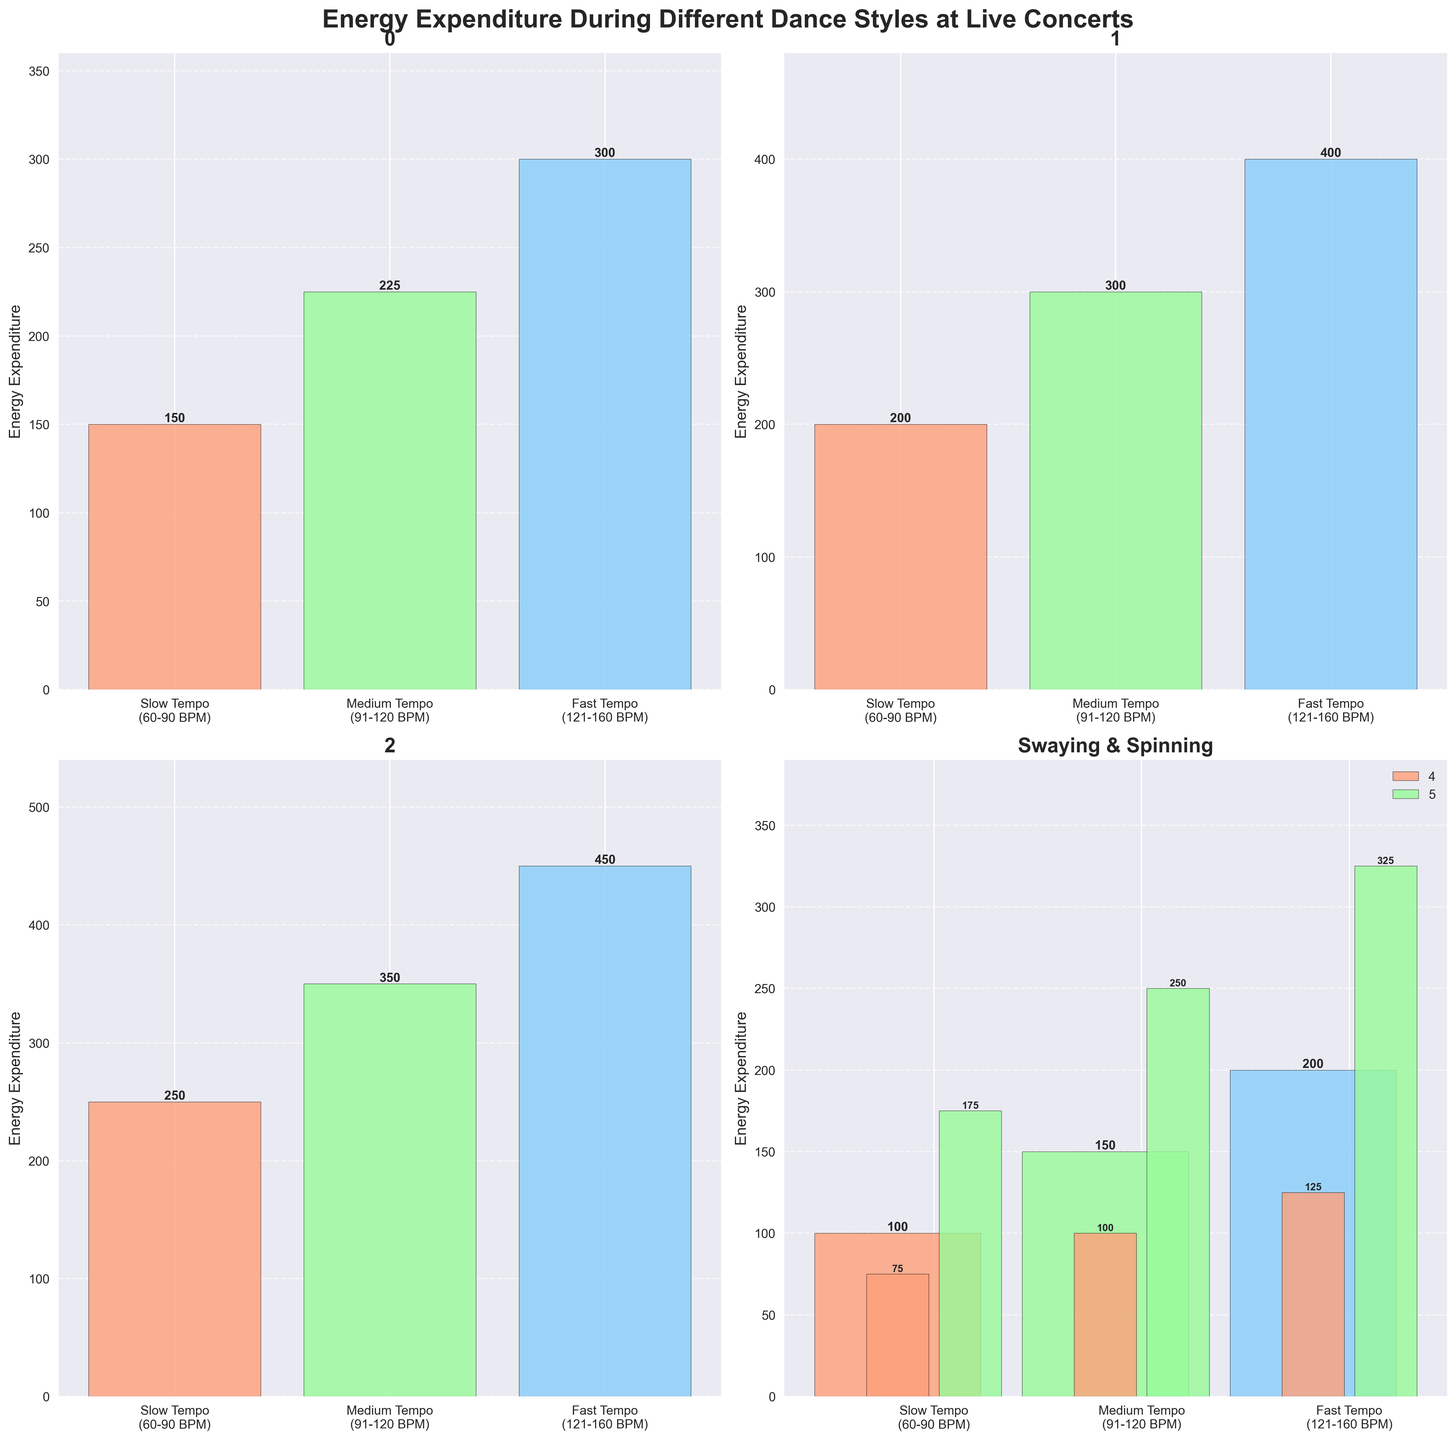What is the title of the entire figure? The title is located at the top center of the figure. It is typically in a larger and bold font to make it stand out.
Answer: Energy Expenditure During Different Dance Styles at Live Concerts How many subplots are there in the figure? Looking at the figure, it can be seen that there are multiple smaller plots within the larger plot. Counting these smaller plots, we see there are four in total.
Answer: Four What is the total energy expenditure for 'Headbanging' across all tempos? To find the total energy expenditure for 'Headbanging', add the values for all tempos: 150 (Slow) + 225 (Medium) + 300 (Fast) = 675.
Answer: 675 Which dance style has the highest energy expenditure at fast tempo? Locate the bar representing the fast tempo (121-160 BPM) for each dance style and compare their heights. The highest bar corresponds to 'Pogo'.
Answer: Pogo What is the difference in energy expenditure between 'Jumping' and 'Arm Waving' at medium tempo? Locate the bars representing the medium tempo (91-120 BPM) for both 'Jumping' and 'Arm Waving', then subtract the value of 'Arm Waving' from 'Jumping': 300 - 150 = 150.
Answer: 150 Which dance style shows the smallest increase in energy expenditure from slow to medium tempo? Calculate the difference in energy expenditure between slow and medium tempos for each dance style. The smallest increase corresponds to the smallest difference. For 'Headbanging' the difference is 225 - 150 = 75, for 'Jumping' it's 300 - 200 = 100, for 'Pogo' it's 350 - 250 = 100, for 'Arm Waving' it's 150 - 100 = 50, for 'Swaying' it's 100 - 75 = 25, and for 'Spinning' it's 250 - 175 = 75. The smallest increase is for 'Swaying.'
Answer: Swaying What are the color codes used for different tempos? The colors representing different tempos are consistent across the bars in the plots. Slow tempo is represented by a color like salmon, medium by light green, and fast by light blue.
Answer: Slow: salmon, Medium: light green, Fast: light blue What is the average energy expenditure for 'Spinning' across all tempos? Calculate the average by summing the values for all tempos and dividing by the number of tempos: (175 + 250 + 325) / 3 = 750 / 3 = 250.
Answer: 250 Which subplot contains data for both 'Swaying' and 'Spinning'? The subplot on the bottom right corner contains data for both 'Swaying' and 'Spinning', as indicated by the joint title "Swaying & Spinning".
Answer: Bottom right corner Which dance style has the smallest overall energy expenditure across all tempos? Sum the energy expenditures across all tempos for each dance style and compare. 'Swaying' has the smallest sum: 75 (Slow) + 100 (Medium) + 125 (Fast) = 300.
Answer: Swaying 